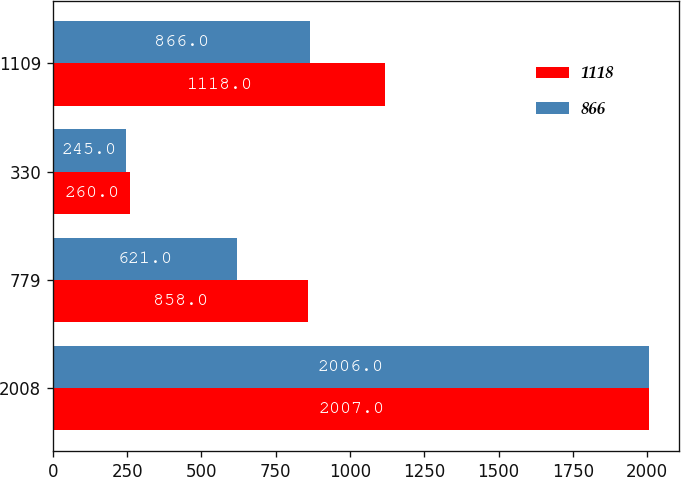Convert chart. <chart><loc_0><loc_0><loc_500><loc_500><stacked_bar_chart><ecel><fcel>2008<fcel>779<fcel>330<fcel>1109<nl><fcel>1118<fcel>2007<fcel>858<fcel>260<fcel>1118<nl><fcel>866<fcel>2006<fcel>621<fcel>245<fcel>866<nl></chart> 